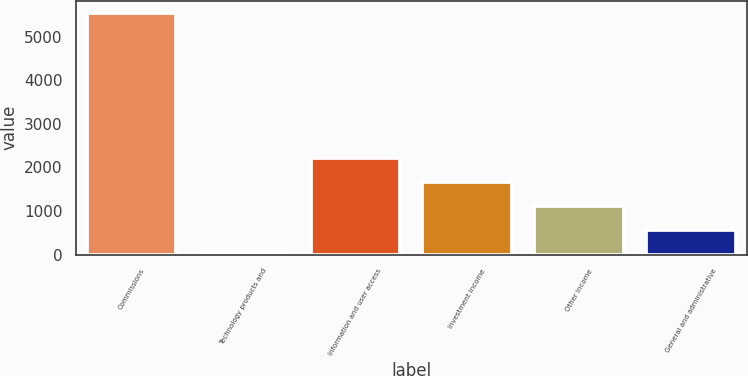Convert chart. <chart><loc_0><loc_0><loc_500><loc_500><bar_chart><fcel>Commissions<fcel>Technology products and<fcel>Information and user access<fcel>Investment income<fcel>Other income<fcel>General and administrative<nl><fcel>5541<fcel>16<fcel>2226<fcel>1673.5<fcel>1121<fcel>568.5<nl></chart> 